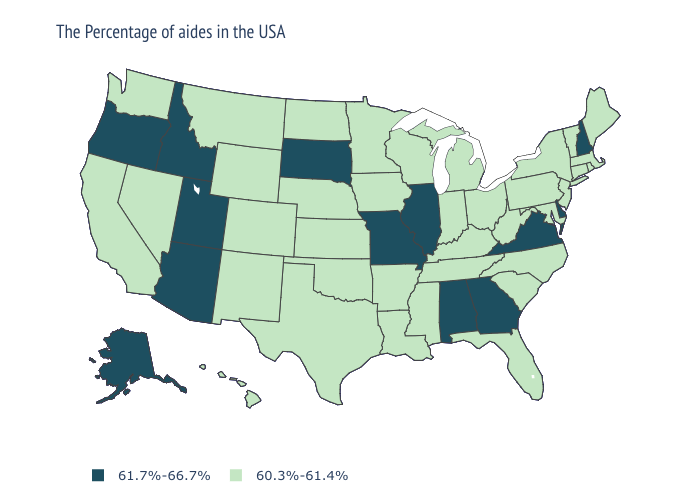Name the states that have a value in the range 61.7%-66.7%?
Answer briefly. New Hampshire, Delaware, Virginia, Georgia, Alabama, Illinois, Missouri, South Dakota, Utah, Arizona, Idaho, Oregon, Alaska. Name the states that have a value in the range 61.7%-66.7%?
Be succinct. New Hampshire, Delaware, Virginia, Georgia, Alabama, Illinois, Missouri, South Dakota, Utah, Arizona, Idaho, Oregon, Alaska. Name the states that have a value in the range 61.7%-66.7%?
Give a very brief answer. New Hampshire, Delaware, Virginia, Georgia, Alabama, Illinois, Missouri, South Dakota, Utah, Arizona, Idaho, Oregon, Alaska. Name the states that have a value in the range 60.3%-61.4%?
Quick response, please. Maine, Massachusetts, Rhode Island, Vermont, Connecticut, New York, New Jersey, Maryland, Pennsylvania, North Carolina, South Carolina, West Virginia, Ohio, Florida, Michigan, Kentucky, Indiana, Tennessee, Wisconsin, Mississippi, Louisiana, Arkansas, Minnesota, Iowa, Kansas, Nebraska, Oklahoma, Texas, North Dakota, Wyoming, Colorado, New Mexico, Montana, Nevada, California, Washington, Hawaii. Name the states that have a value in the range 61.7%-66.7%?
Keep it brief. New Hampshire, Delaware, Virginia, Georgia, Alabama, Illinois, Missouri, South Dakota, Utah, Arizona, Idaho, Oregon, Alaska. How many symbols are there in the legend?
Give a very brief answer. 2. What is the lowest value in the MidWest?
Be succinct. 60.3%-61.4%. What is the lowest value in the USA?
Write a very short answer. 60.3%-61.4%. What is the value of Nebraska?
Short answer required. 60.3%-61.4%. Which states have the lowest value in the MidWest?
Quick response, please. Ohio, Michigan, Indiana, Wisconsin, Minnesota, Iowa, Kansas, Nebraska, North Dakota. What is the value of New Mexico?
Keep it brief. 60.3%-61.4%. Name the states that have a value in the range 60.3%-61.4%?
Concise answer only. Maine, Massachusetts, Rhode Island, Vermont, Connecticut, New York, New Jersey, Maryland, Pennsylvania, North Carolina, South Carolina, West Virginia, Ohio, Florida, Michigan, Kentucky, Indiana, Tennessee, Wisconsin, Mississippi, Louisiana, Arkansas, Minnesota, Iowa, Kansas, Nebraska, Oklahoma, Texas, North Dakota, Wyoming, Colorado, New Mexico, Montana, Nevada, California, Washington, Hawaii. Does Illinois have the highest value in the USA?
Short answer required. Yes. Is the legend a continuous bar?
Answer briefly. No. Among the states that border Utah , which have the lowest value?
Give a very brief answer. Wyoming, Colorado, New Mexico, Nevada. 